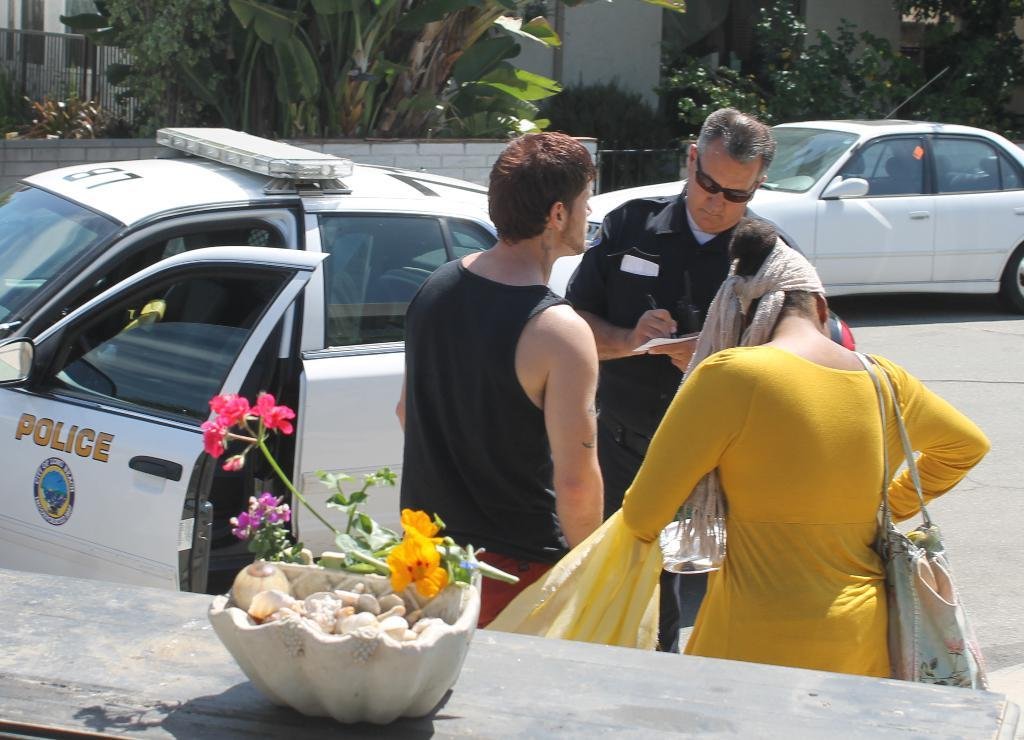<image>
Describe the image concisely. A City of Long Beach Police officer writes a statement while talking to a man and a women outside his car. 